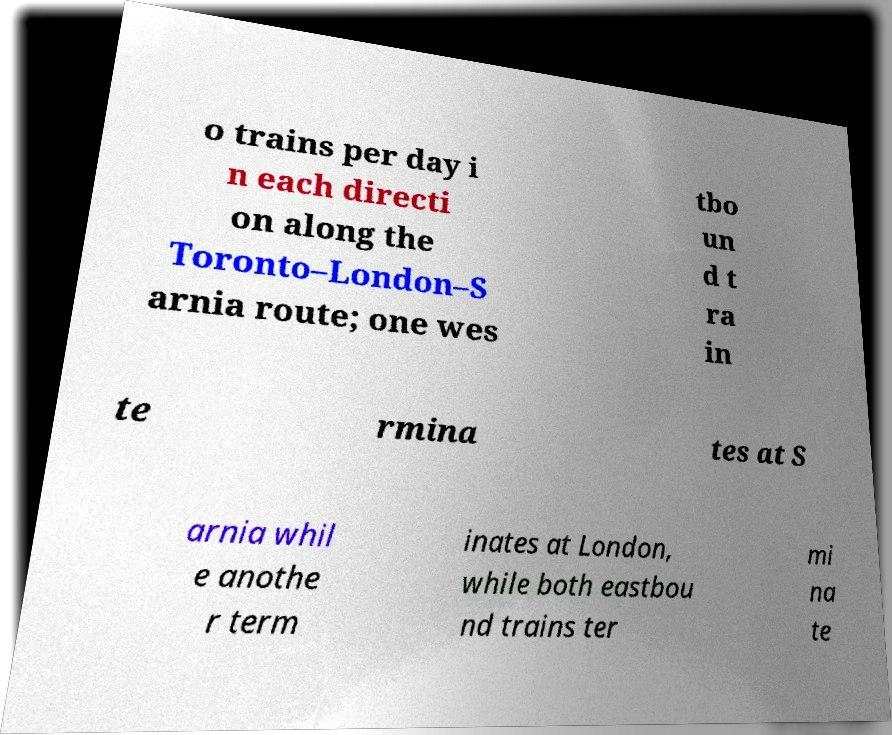What messages or text are displayed in this image? I need them in a readable, typed format. o trains per day i n each directi on along the Toronto–London–S arnia route; one wes tbo un d t ra in te rmina tes at S arnia whil e anothe r term inates at London, while both eastbou nd trains ter mi na te 